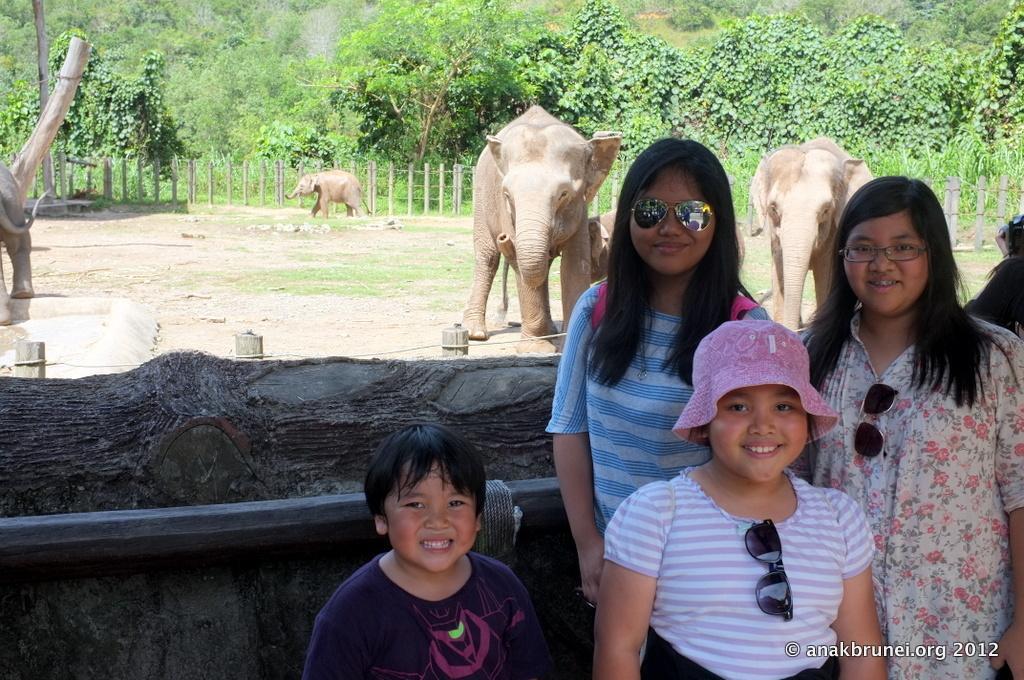Could you give a brief overview of what you see in this image? In the picture I can see people are standing on the ground and smiling. In the background I can see elephants on the ground, trees, fence, plants and some other objects. 